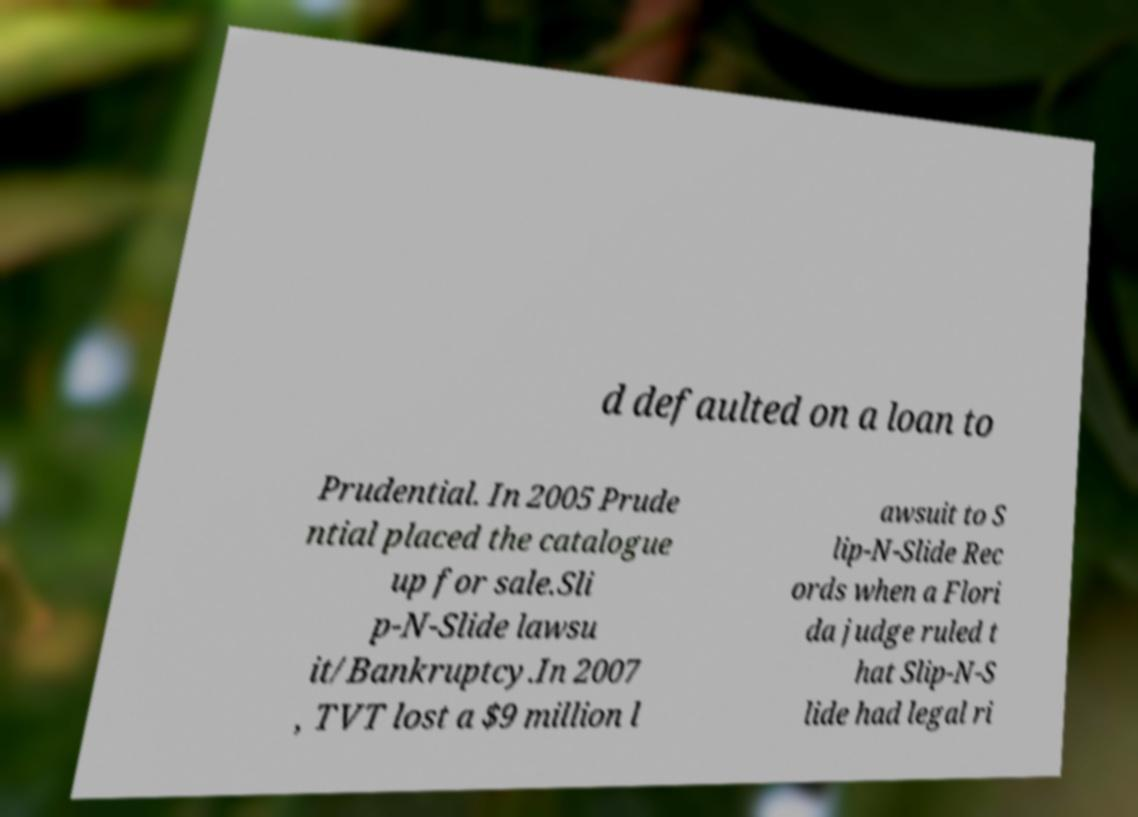For documentation purposes, I need the text within this image transcribed. Could you provide that? d defaulted on a loan to Prudential. In 2005 Prude ntial placed the catalogue up for sale.Sli p-N-Slide lawsu it/Bankruptcy.In 2007 , TVT lost a $9 million l awsuit to S lip-N-Slide Rec ords when a Flori da judge ruled t hat Slip-N-S lide had legal ri 